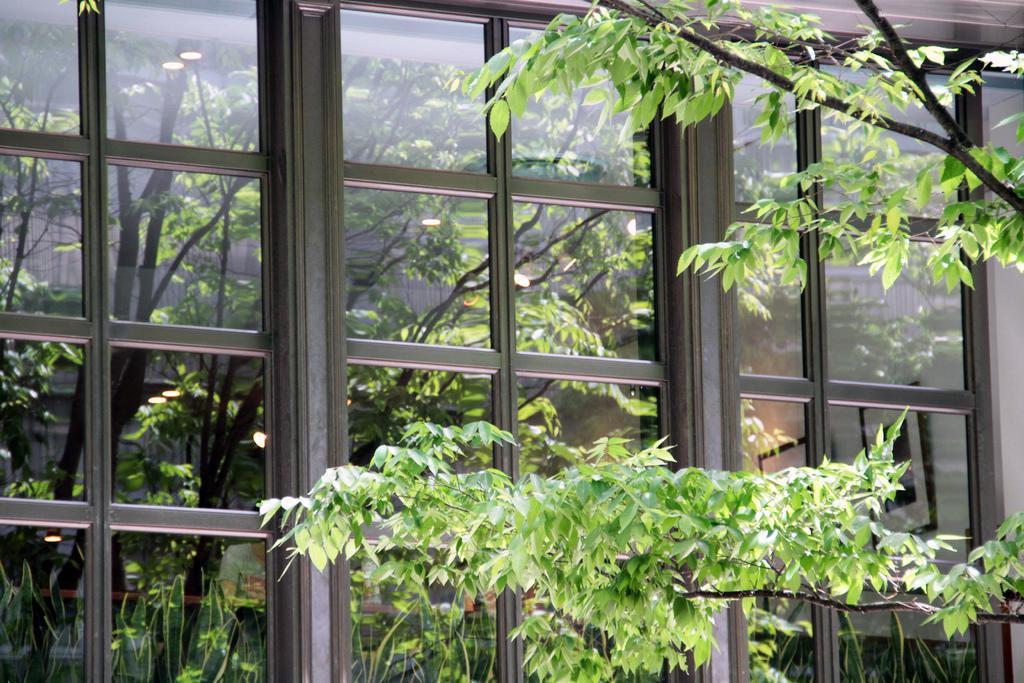How would you summarize this image in a sentence or two? On the right side there are stems, in the background there is a glass window. 